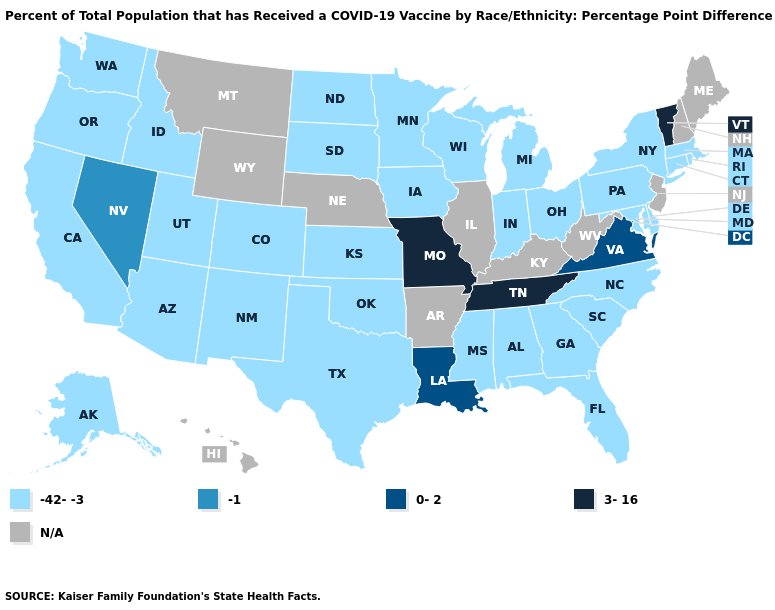What is the highest value in the USA?
Give a very brief answer. 3-16. Name the states that have a value in the range 3-16?
Short answer required. Missouri, Tennessee, Vermont. What is the value of Indiana?
Short answer required. -42--3. Name the states that have a value in the range N/A?
Give a very brief answer. Arkansas, Hawaii, Illinois, Kentucky, Maine, Montana, Nebraska, New Hampshire, New Jersey, West Virginia, Wyoming. Does the first symbol in the legend represent the smallest category?
Keep it brief. Yes. Name the states that have a value in the range 3-16?
Be succinct. Missouri, Tennessee, Vermont. Which states have the lowest value in the West?
Quick response, please. Alaska, Arizona, California, Colorado, Idaho, New Mexico, Oregon, Utah, Washington. What is the value of Hawaii?
Short answer required. N/A. Which states have the lowest value in the USA?
Write a very short answer. Alabama, Alaska, Arizona, California, Colorado, Connecticut, Delaware, Florida, Georgia, Idaho, Indiana, Iowa, Kansas, Maryland, Massachusetts, Michigan, Minnesota, Mississippi, New Mexico, New York, North Carolina, North Dakota, Ohio, Oklahoma, Oregon, Pennsylvania, Rhode Island, South Carolina, South Dakota, Texas, Utah, Washington, Wisconsin. Name the states that have a value in the range -42--3?
Answer briefly. Alabama, Alaska, Arizona, California, Colorado, Connecticut, Delaware, Florida, Georgia, Idaho, Indiana, Iowa, Kansas, Maryland, Massachusetts, Michigan, Minnesota, Mississippi, New Mexico, New York, North Carolina, North Dakota, Ohio, Oklahoma, Oregon, Pennsylvania, Rhode Island, South Carolina, South Dakota, Texas, Utah, Washington, Wisconsin. What is the value of Illinois?
Be succinct. N/A. What is the value of Michigan?
Keep it brief. -42--3. Does Vermont have the lowest value in the Northeast?
Concise answer only. No. Name the states that have a value in the range 0-2?
Write a very short answer. Louisiana, Virginia. Which states hav the highest value in the West?
Concise answer only. Nevada. 